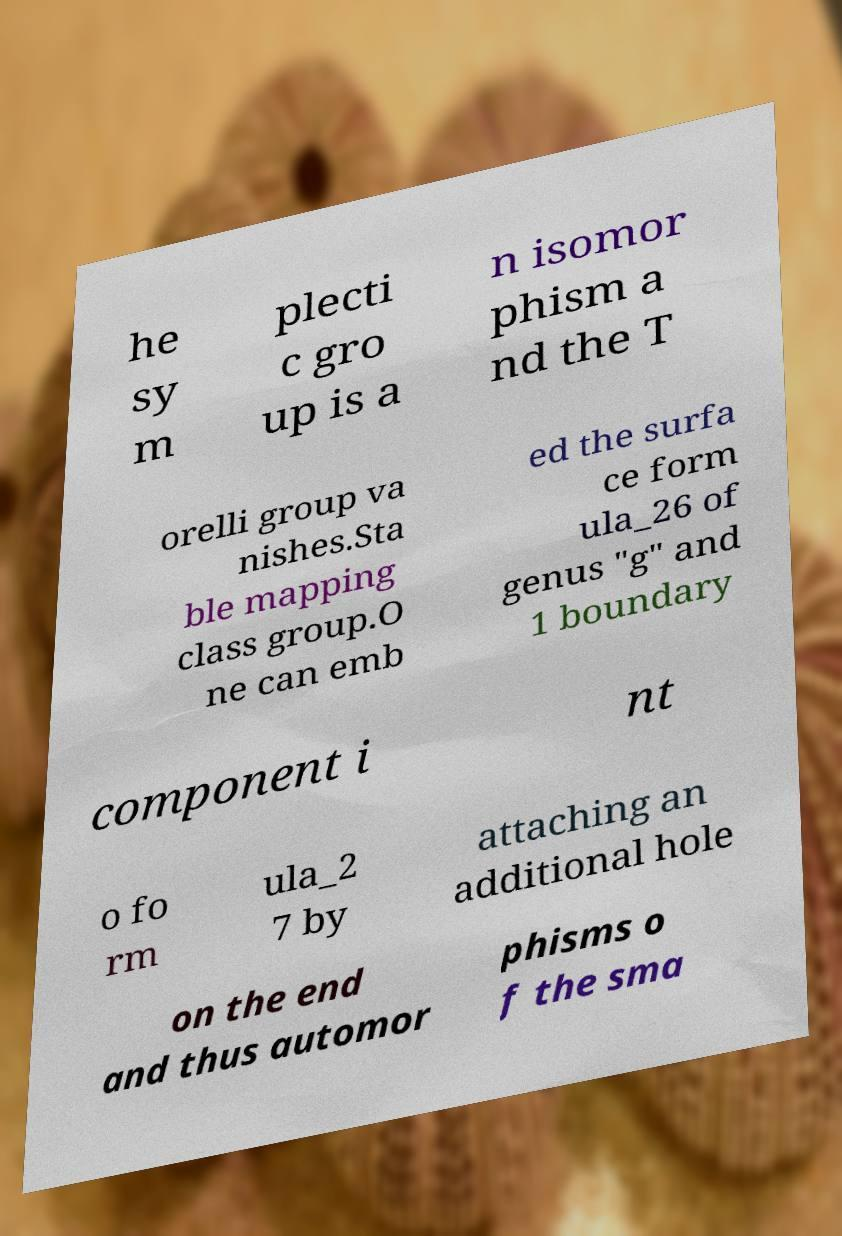Can you read and provide the text displayed in the image?This photo seems to have some interesting text. Can you extract and type it out for me? he sy m plecti c gro up is a n isomor phism a nd the T orelli group va nishes.Sta ble mapping class group.O ne can emb ed the surfa ce form ula_26 of genus "g" and 1 boundary component i nt o fo rm ula_2 7 by attaching an additional hole on the end and thus automor phisms o f the sma 